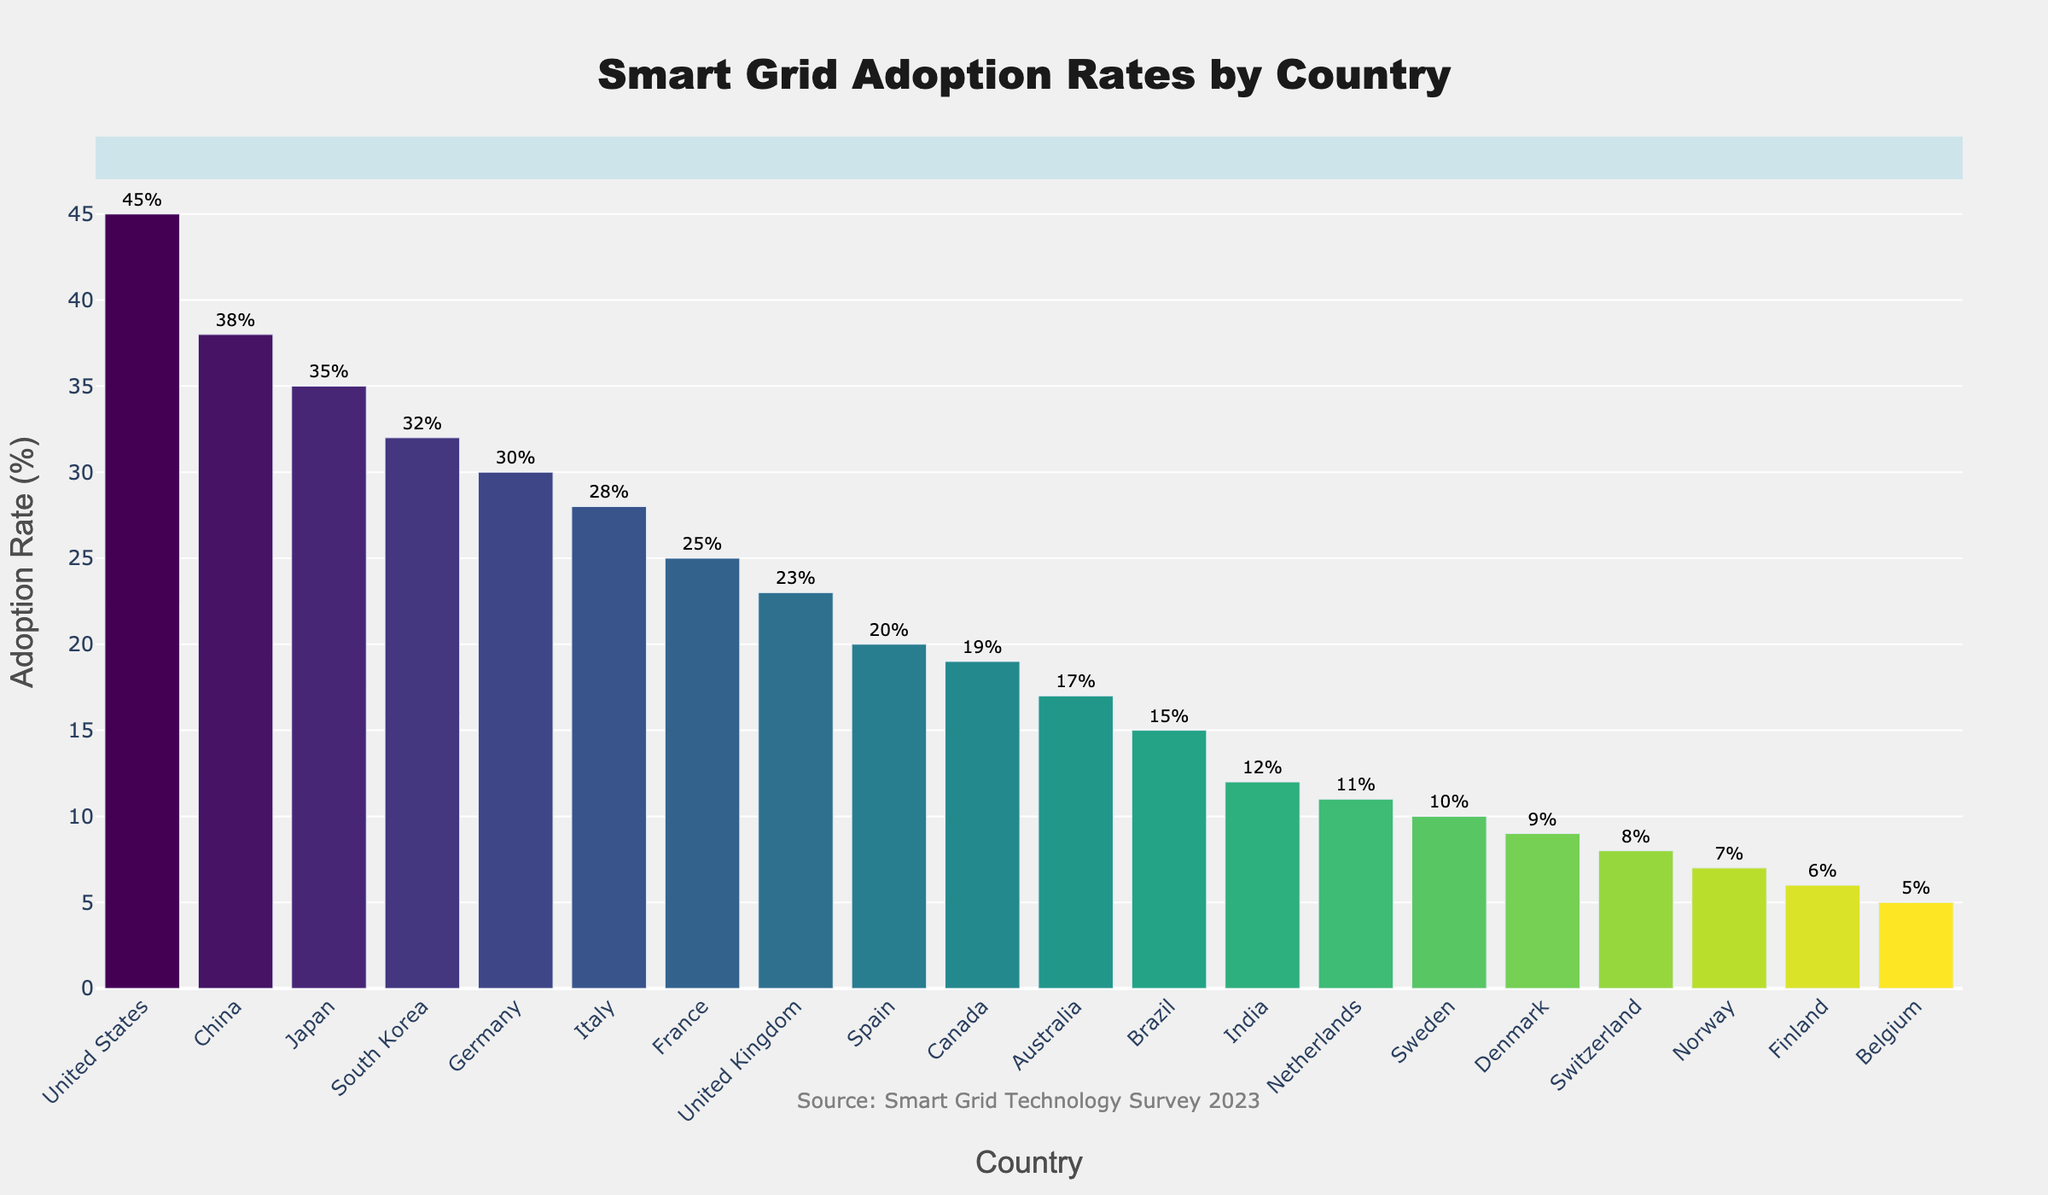Which country has the highest adoption rate of smart grid technologies? The bar chart shows the adoption rates of smart grid technologies by country, with the United States having the highest bar and a corresponding rate of 45%.
Answer: United States Which country has the lowest adoption rate of smart grid technologies? By examining the chart, we see that Belgium has the shortest bar among all countries and an adoption rate of 5%.
Answer: Belgium What is the difference in adoption rates between the United States and China? The adoption rate for the United States is 45%, while for China, it's 38%. The difference is calculated by subtracting China's rate from the United States' rate: 45% - 38% = 7%.
Answer: 7% What is the average adoption rate of the top five countries? The top five countries are the United States (45%), China (38%), Japan (35%), South Korea (32%), and Germany (30%). The average is calculated by summing these rates and dividing by 5: (45 + 38 + 35 + 32 + 30) / 5 = 36.
Answer: 36% Which countries have an adoption rate higher than the average adoption rate? The average adoption rate is (45 + 38 + 35 + 32 + 30 + 28 + 25 + 23 + 20 + 19 + 17 + 15 + 12 + 11 + 10 + 9 + 8 + 7 + 6 + 5) / 20 = 20.75%. The countries with adoption rates higher than this value are the United States, China, Japan, South Korea, Germany, Italy, and France.
Answer: United States, China, Japan, South Korea, Germany, Italy, France Which country ranks fifth in smart grid adoption? Sorting the countries by their adoption rates, the fifth country is Germany with an adoption rate of 30%.
Answer: Germany What is the combined adoption rate of France, United Kingdom, and Spain? The adoption rates are France (25%), United Kingdom (23%), and Spain (20%). Summing these rates: 25% + 23% + 20% = 68%.
Answer: 68% How many countries have an adoption rate of less than 20%? The countries with adoption rates below 20% are Spain (20%), Canada (19%), Australia (17%), Brazil (15%), India (12%), Netherlands (11%), Sweden (10%), Denmark (9%), Switzerland (8%), Norway (7%), Finland (6%), and Belgium (5%). Counting these countries, there are 12 in total.
Answer: 12 Which countries have an adoption rate very close to the average (within ±1%)? The average adoption rate is 20.75%. The countries within ±1% of the average are Spain (20%) and United Kingdom (23%), which are just slightly outside the range. Therefore, no countries fall into this range exactly.
Answer: None What is the proportion of countries with an adoption rate above 30% relative to the total number of countries? The countries with adoption rates above 30% are the United States, China, Japan, South Korea, and Germany. There are 5 such countries out of a total of 20 countries, so the proportion is \( \frac{5}{20} \times 100 = 25\% \).
Answer: 25% 